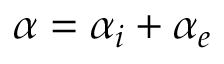Convert formula to latex. <formula><loc_0><loc_0><loc_500><loc_500>\alpha = \alpha _ { i } + \alpha _ { e }</formula> 